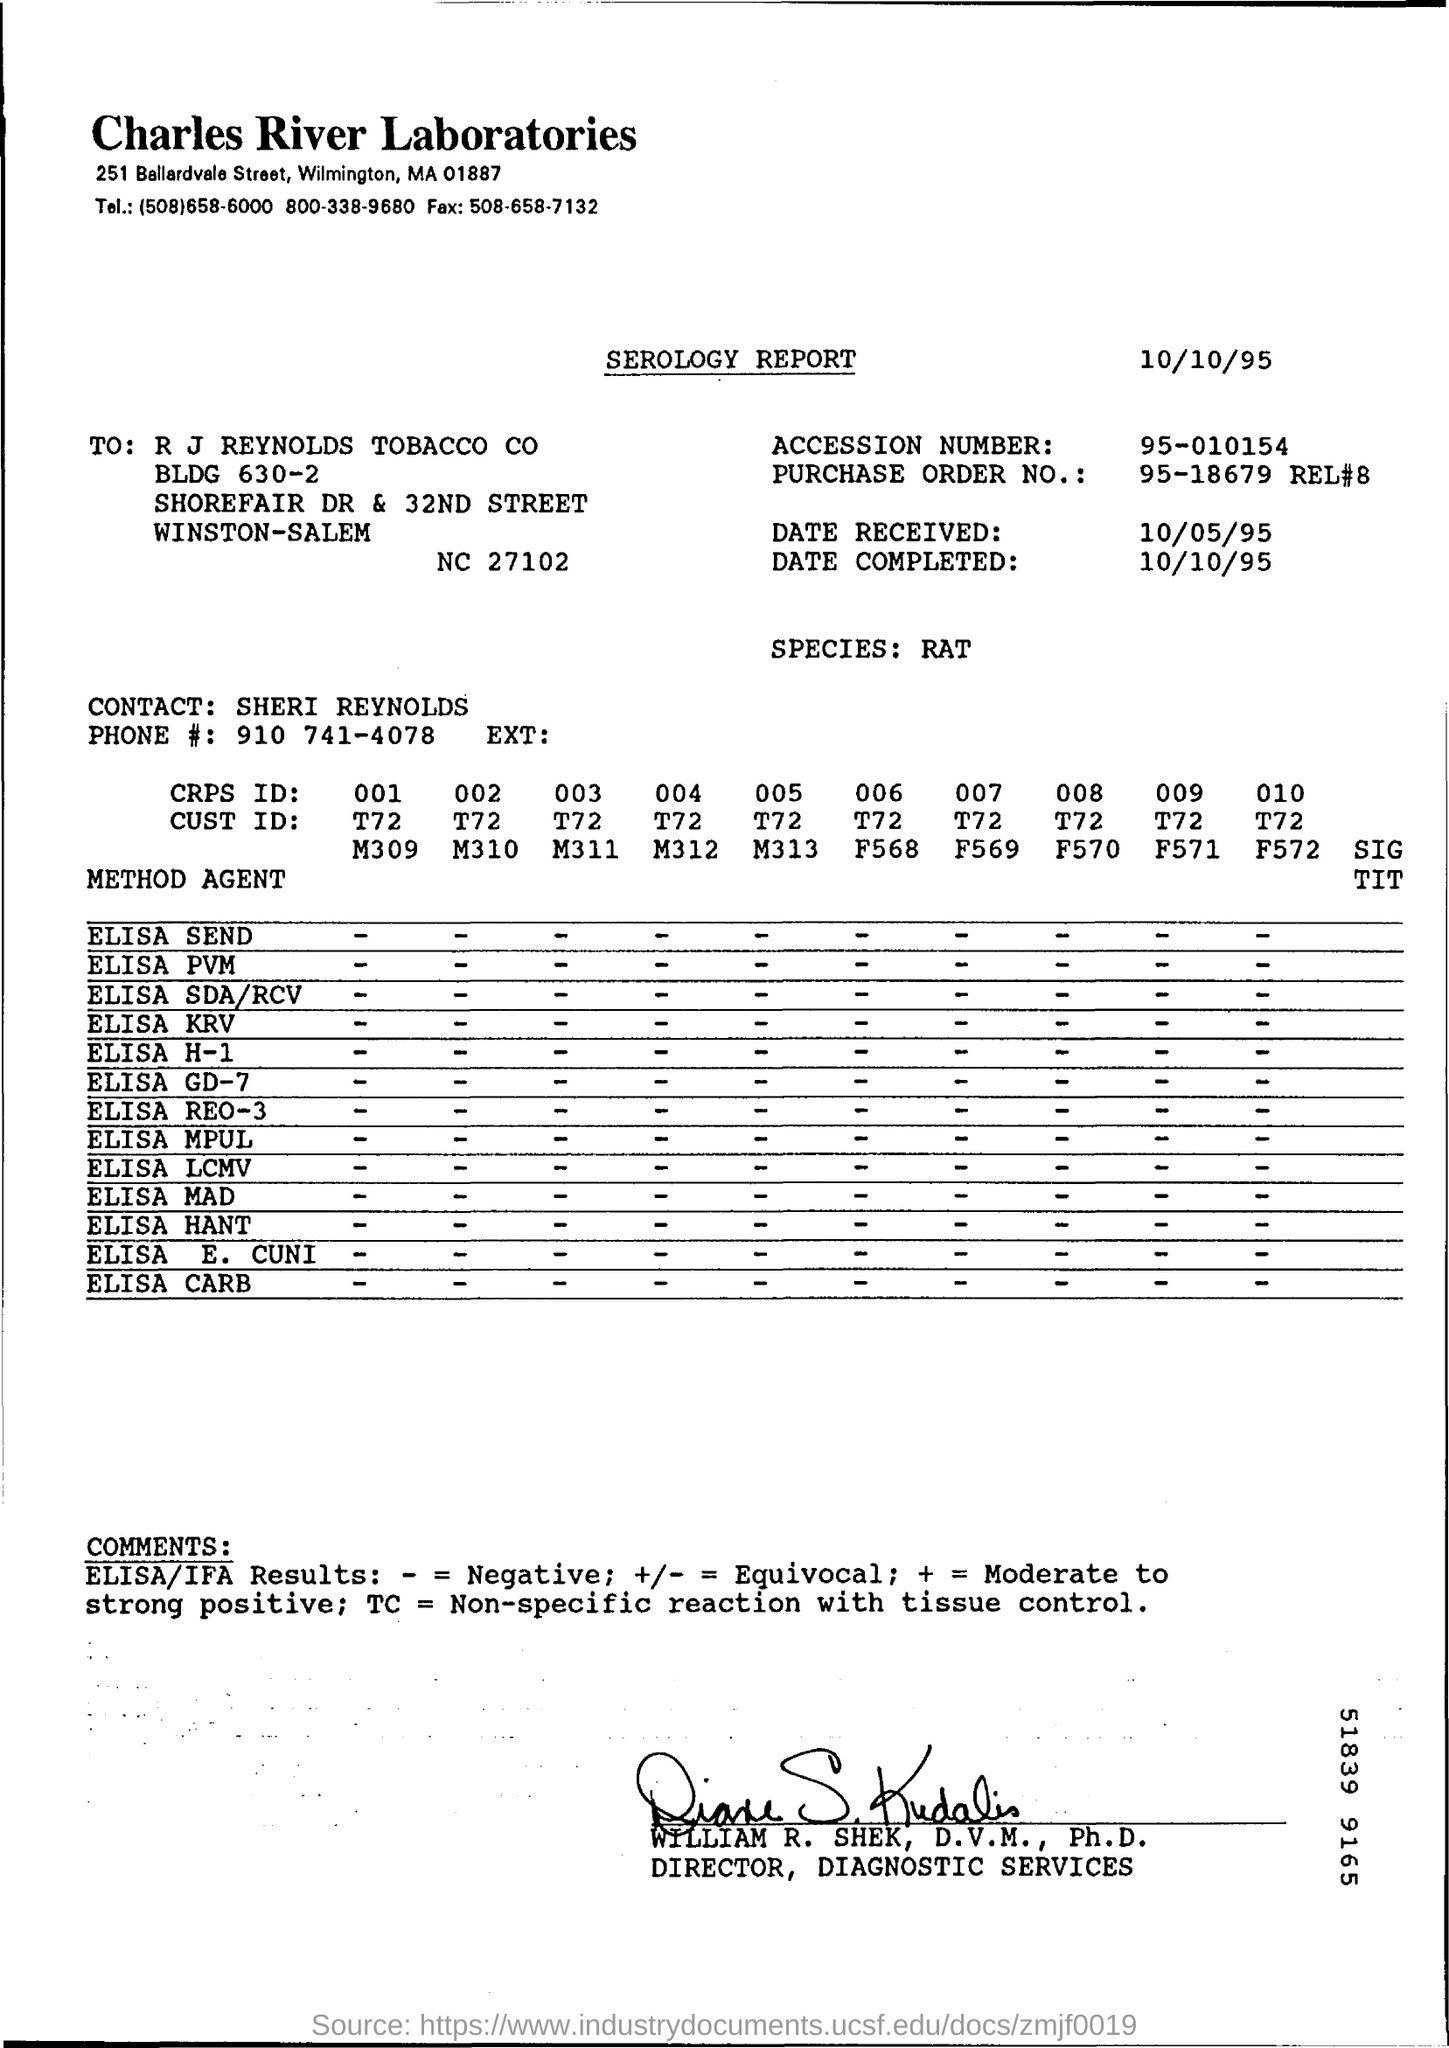What is the name of the laboratory?
Keep it short and to the point. Charles river laboratories. In which city is Charles river laboratories located?
Offer a terse response. Wilmington. The report belongs to which species?
Offer a terse response. RAT. What type of report is mentioned?
Ensure brevity in your answer.  Serology report. What is the date of completion of the serology report?
Provide a succinct answer. 10/10/95. 